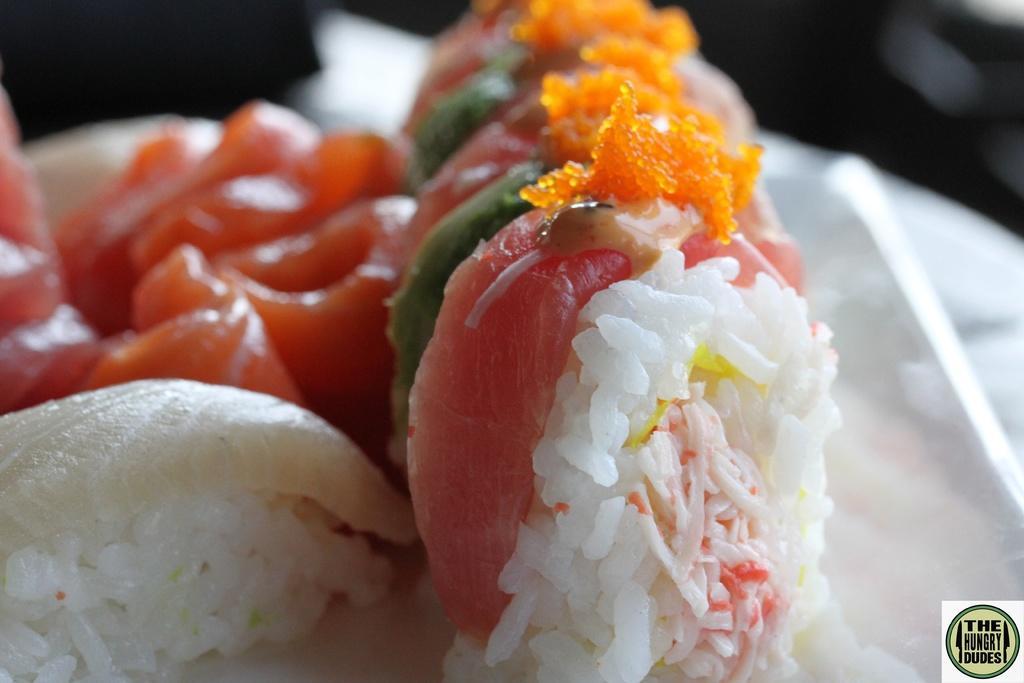Could you give a brief overview of what you see in this image? Here we can see rice and food items. In the background the image is not clear to describe the objects. 